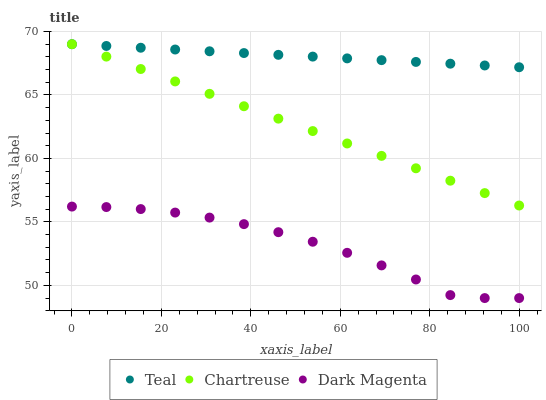Does Dark Magenta have the minimum area under the curve?
Answer yes or no. Yes. Does Teal have the maximum area under the curve?
Answer yes or no. Yes. Does Teal have the minimum area under the curve?
Answer yes or no. No. Does Dark Magenta have the maximum area under the curve?
Answer yes or no. No. Is Chartreuse the smoothest?
Answer yes or no. Yes. Is Dark Magenta the roughest?
Answer yes or no. Yes. Is Teal the smoothest?
Answer yes or no. No. Is Teal the roughest?
Answer yes or no. No. Does Dark Magenta have the lowest value?
Answer yes or no. Yes. Does Teal have the lowest value?
Answer yes or no. No. Does Teal have the highest value?
Answer yes or no. Yes. Does Dark Magenta have the highest value?
Answer yes or no. No. Is Dark Magenta less than Chartreuse?
Answer yes or no. Yes. Is Teal greater than Dark Magenta?
Answer yes or no. Yes. Does Chartreuse intersect Teal?
Answer yes or no. Yes. Is Chartreuse less than Teal?
Answer yes or no. No. Is Chartreuse greater than Teal?
Answer yes or no. No. Does Dark Magenta intersect Chartreuse?
Answer yes or no. No. 